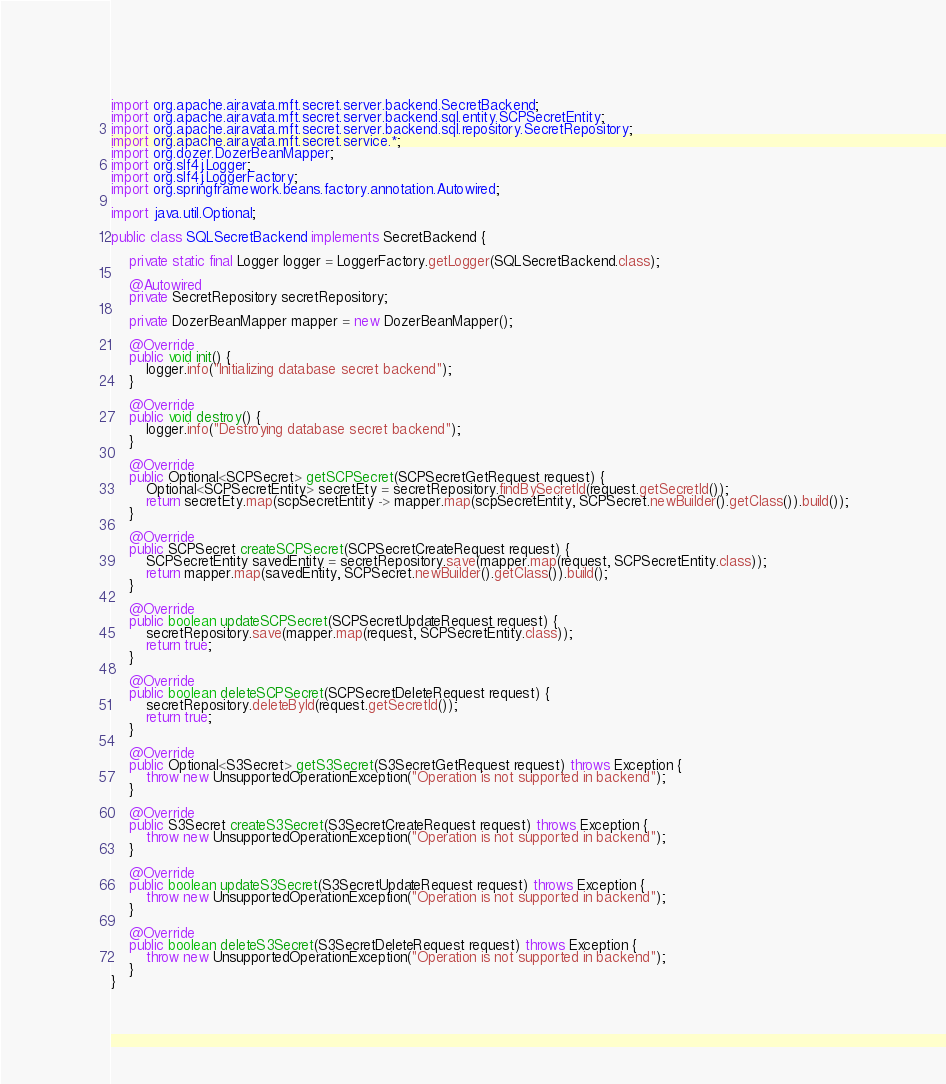<code> <loc_0><loc_0><loc_500><loc_500><_Java_>import org.apache.airavata.mft.secret.server.backend.SecretBackend;
import org.apache.airavata.mft.secret.server.backend.sql.entity.SCPSecretEntity;
import org.apache.airavata.mft.secret.server.backend.sql.repository.SecretRepository;
import org.apache.airavata.mft.secret.service.*;
import org.dozer.DozerBeanMapper;
import org.slf4j.Logger;
import org.slf4j.LoggerFactory;
import org.springframework.beans.factory.annotation.Autowired;

import java.util.Optional;

public class SQLSecretBackend implements SecretBackend {

    private static final Logger logger = LoggerFactory.getLogger(SQLSecretBackend.class);

    @Autowired
    private SecretRepository secretRepository;

    private DozerBeanMapper mapper = new DozerBeanMapper();

    @Override
    public void init() {
        logger.info("Initializing database secret backend");
    }

    @Override
    public void destroy() {
        logger.info("Destroying database secret backend");
    }

    @Override
    public Optional<SCPSecret> getSCPSecret(SCPSecretGetRequest request) {
        Optional<SCPSecretEntity> secretEty = secretRepository.findBySecretId(request.getSecretId());
        return secretEty.map(scpSecretEntity -> mapper.map(scpSecretEntity, SCPSecret.newBuilder().getClass()).build());
    }

    @Override
    public SCPSecret createSCPSecret(SCPSecretCreateRequest request) {
        SCPSecretEntity savedEntity = secretRepository.save(mapper.map(request, SCPSecretEntity.class));
        return mapper.map(savedEntity, SCPSecret.newBuilder().getClass()).build();
    }

    @Override
    public boolean updateSCPSecret(SCPSecretUpdateRequest request) {
        secretRepository.save(mapper.map(request, SCPSecretEntity.class));
        return true;
    }

    @Override
    public boolean deleteSCPSecret(SCPSecretDeleteRequest request) {
        secretRepository.deleteById(request.getSecretId());
        return true;
    }

    @Override
    public Optional<S3Secret> getS3Secret(S3SecretGetRequest request) throws Exception {
        throw new UnsupportedOperationException("Operation is not supported in backend");
    }

    @Override
    public S3Secret createS3Secret(S3SecretCreateRequest request) throws Exception {
        throw new UnsupportedOperationException("Operation is not supported in backend");
    }

    @Override
    public boolean updateS3Secret(S3SecretUpdateRequest request) throws Exception {
        throw new UnsupportedOperationException("Operation is not supported in backend");
    }

    @Override
    public boolean deleteS3Secret(S3SecretDeleteRequest request) throws Exception {
        throw new UnsupportedOperationException("Operation is not supported in backend");
    }
}
</code> 